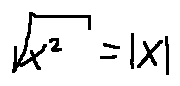Convert formula to latex. <formula><loc_0><loc_0><loc_500><loc_500>\sqrt { x ^ { 2 } } = | x |</formula> 